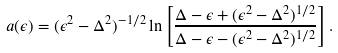Convert formula to latex. <formula><loc_0><loc_0><loc_500><loc_500>a ( \epsilon ) = ( \epsilon ^ { 2 } - \Delta ^ { 2 } ) ^ { - 1 / 2 } \ln \left [ \frac { \Delta - \epsilon + ( \epsilon ^ { 2 } - \Delta ^ { 2 } ) ^ { 1 / 2 } } { \Delta - \epsilon - ( \epsilon ^ { 2 } - \Delta ^ { 2 } ) ^ { 1 / 2 } } \right ] .</formula> 